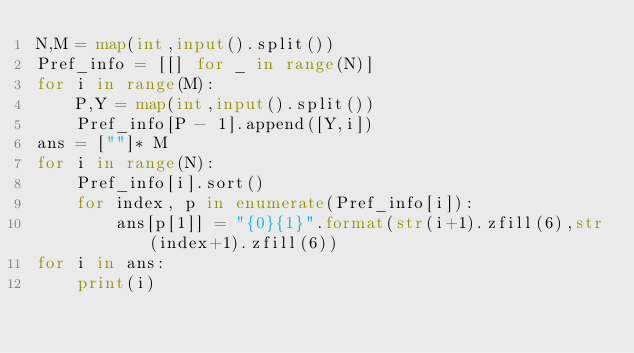Convert code to text. <code><loc_0><loc_0><loc_500><loc_500><_Python_>N,M = map(int,input().split()) 
Pref_info = [[] for _ in range(N)] 
for i in range(M):
    P,Y = map(int,input().split())
    Pref_info[P - 1].append([Y,i])
ans = [""]* M 
for i in range(N): 
    Pref_info[i].sort()
    for index, p in enumerate(Pref_info[i]):
        ans[p[1]] = "{0}{1}".format(str(i+1).zfill(6),str(index+1).zfill(6))
for i in ans:
    print(i)</code> 